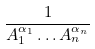Convert formula to latex. <formula><loc_0><loc_0><loc_500><loc_500>\frac { 1 } { A _ { 1 } ^ { \alpha _ { 1 } } \dots A _ { n } ^ { \alpha _ { n } } }</formula> 